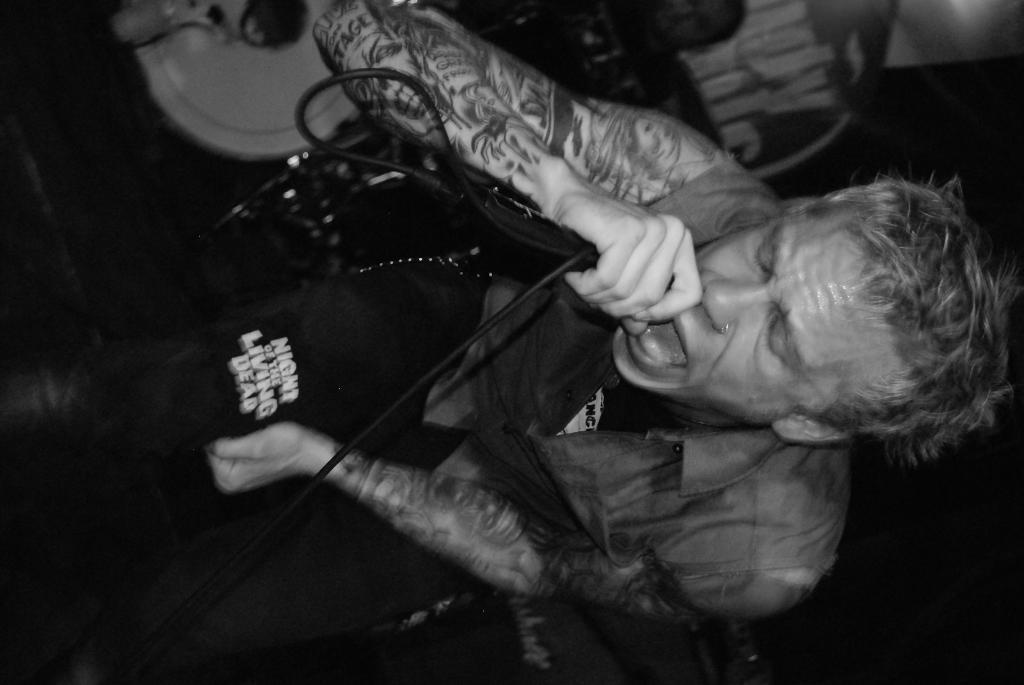Can you describe this image briefly? In this image I can see a person is holding something. I can see few objects around and tattoos on his hands. The image is in black and white. 